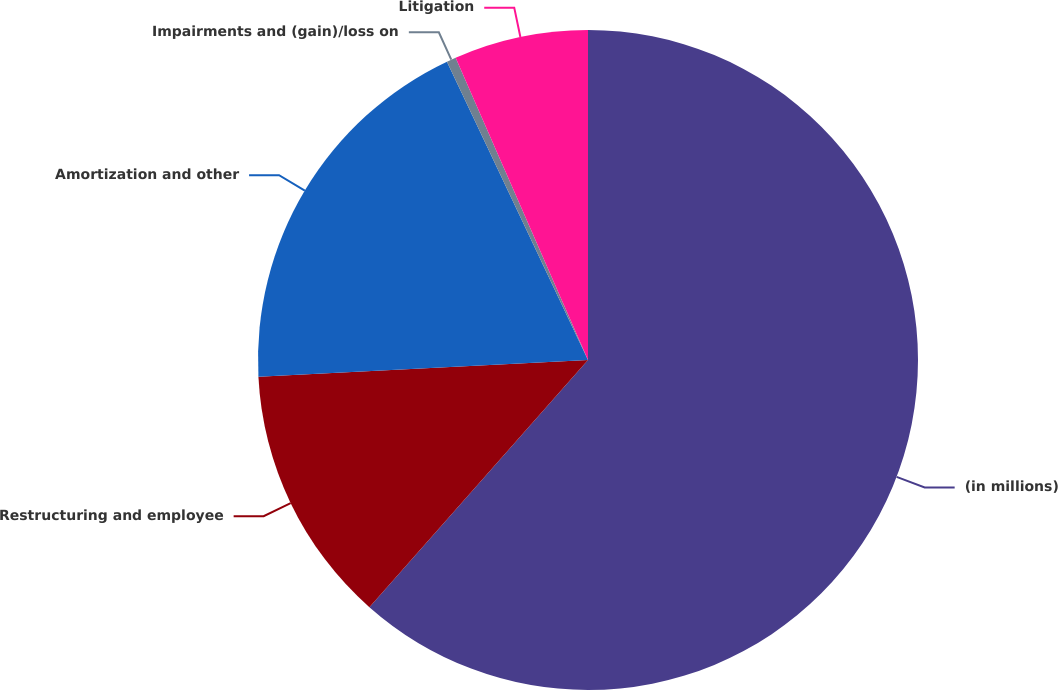<chart> <loc_0><loc_0><loc_500><loc_500><pie_chart><fcel>(in millions)<fcel>Restructuring and employee<fcel>Amortization and other<fcel>Impairments and (gain)/loss on<fcel>Litigation<nl><fcel>61.53%<fcel>12.67%<fcel>18.78%<fcel>0.46%<fcel>6.57%<nl></chart> 